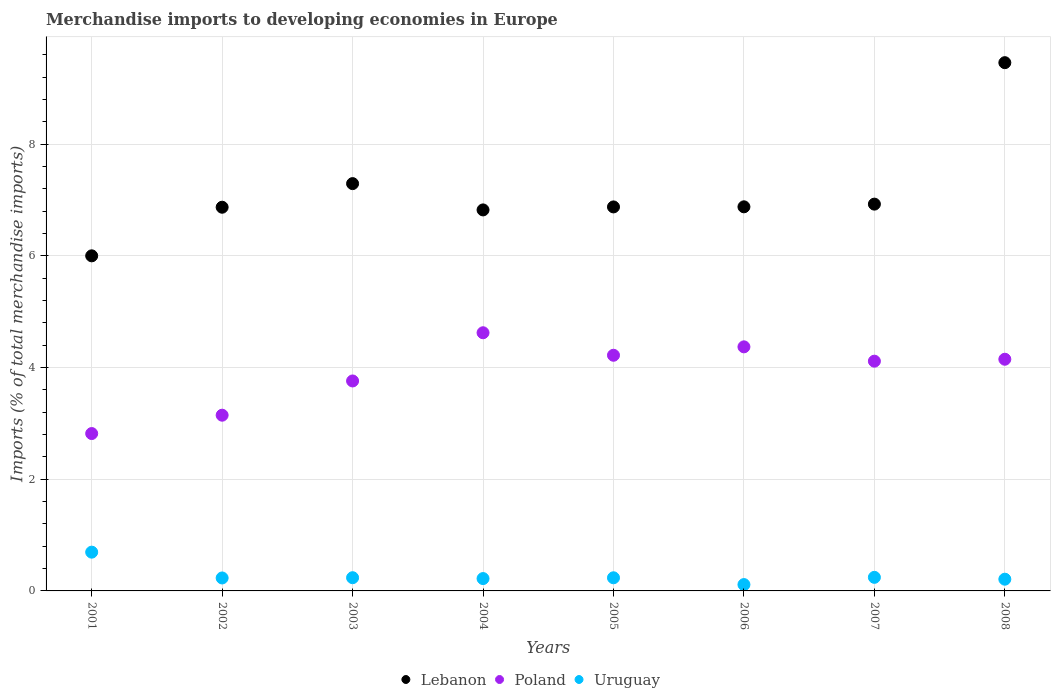How many different coloured dotlines are there?
Offer a very short reply. 3. What is the percentage total merchandise imports in Lebanon in 2005?
Give a very brief answer. 6.88. Across all years, what is the maximum percentage total merchandise imports in Lebanon?
Make the answer very short. 9.46. Across all years, what is the minimum percentage total merchandise imports in Poland?
Your response must be concise. 2.82. In which year was the percentage total merchandise imports in Lebanon maximum?
Your answer should be very brief. 2008. What is the total percentage total merchandise imports in Poland in the graph?
Ensure brevity in your answer.  31.21. What is the difference between the percentage total merchandise imports in Poland in 2001 and that in 2007?
Ensure brevity in your answer.  -1.3. What is the difference between the percentage total merchandise imports in Lebanon in 2003 and the percentage total merchandise imports in Uruguay in 2001?
Ensure brevity in your answer.  6.6. What is the average percentage total merchandise imports in Poland per year?
Provide a short and direct response. 3.9. In the year 2002, what is the difference between the percentage total merchandise imports in Lebanon and percentage total merchandise imports in Uruguay?
Offer a very short reply. 6.64. In how many years, is the percentage total merchandise imports in Lebanon greater than 1.2000000000000002 %?
Keep it short and to the point. 8. What is the ratio of the percentage total merchandise imports in Uruguay in 2007 to that in 2008?
Your answer should be compact. 1.16. Is the percentage total merchandise imports in Uruguay in 2004 less than that in 2006?
Make the answer very short. No. Is the difference between the percentage total merchandise imports in Lebanon in 2005 and 2008 greater than the difference between the percentage total merchandise imports in Uruguay in 2005 and 2008?
Make the answer very short. No. What is the difference between the highest and the second highest percentage total merchandise imports in Lebanon?
Your response must be concise. 2.17. What is the difference between the highest and the lowest percentage total merchandise imports in Lebanon?
Give a very brief answer. 3.46. In how many years, is the percentage total merchandise imports in Lebanon greater than the average percentage total merchandise imports in Lebanon taken over all years?
Provide a succinct answer. 2. Does the percentage total merchandise imports in Lebanon monotonically increase over the years?
Make the answer very short. No. Is the percentage total merchandise imports in Poland strictly greater than the percentage total merchandise imports in Uruguay over the years?
Offer a terse response. Yes. What is the difference between two consecutive major ticks on the Y-axis?
Give a very brief answer. 2. Are the values on the major ticks of Y-axis written in scientific E-notation?
Offer a terse response. No. Does the graph contain any zero values?
Your answer should be very brief. No. Does the graph contain grids?
Make the answer very short. Yes. How are the legend labels stacked?
Give a very brief answer. Horizontal. What is the title of the graph?
Your response must be concise. Merchandise imports to developing economies in Europe. Does "Uzbekistan" appear as one of the legend labels in the graph?
Offer a terse response. No. What is the label or title of the X-axis?
Make the answer very short. Years. What is the label or title of the Y-axis?
Provide a succinct answer. Imports (% of total merchandise imports). What is the Imports (% of total merchandise imports) of Lebanon in 2001?
Offer a very short reply. 6. What is the Imports (% of total merchandise imports) in Poland in 2001?
Make the answer very short. 2.82. What is the Imports (% of total merchandise imports) in Uruguay in 2001?
Your response must be concise. 0.69. What is the Imports (% of total merchandise imports) in Lebanon in 2002?
Make the answer very short. 6.87. What is the Imports (% of total merchandise imports) of Poland in 2002?
Your response must be concise. 3.15. What is the Imports (% of total merchandise imports) in Uruguay in 2002?
Provide a short and direct response. 0.23. What is the Imports (% of total merchandise imports) in Lebanon in 2003?
Provide a succinct answer. 7.3. What is the Imports (% of total merchandise imports) in Poland in 2003?
Give a very brief answer. 3.76. What is the Imports (% of total merchandise imports) of Uruguay in 2003?
Your answer should be very brief. 0.24. What is the Imports (% of total merchandise imports) of Lebanon in 2004?
Make the answer very short. 6.82. What is the Imports (% of total merchandise imports) in Poland in 2004?
Provide a short and direct response. 4.62. What is the Imports (% of total merchandise imports) of Uruguay in 2004?
Give a very brief answer. 0.22. What is the Imports (% of total merchandise imports) of Lebanon in 2005?
Your answer should be compact. 6.88. What is the Imports (% of total merchandise imports) in Poland in 2005?
Provide a short and direct response. 4.22. What is the Imports (% of total merchandise imports) of Uruguay in 2005?
Your response must be concise. 0.24. What is the Imports (% of total merchandise imports) of Lebanon in 2006?
Ensure brevity in your answer.  6.88. What is the Imports (% of total merchandise imports) in Poland in 2006?
Your answer should be compact. 4.37. What is the Imports (% of total merchandise imports) in Uruguay in 2006?
Ensure brevity in your answer.  0.11. What is the Imports (% of total merchandise imports) of Lebanon in 2007?
Your answer should be compact. 6.93. What is the Imports (% of total merchandise imports) of Poland in 2007?
Keep it short and to the point. 4.11. What is the Imports (% of total merchandise imports) of Uruguay in 2007?
Ensure brevity in your answer.  0.24. What is the Imports (% of total merchandise imports) of Lebanon in 2008?
Give a very brief answer. 9.46. What is the Imports (% of total merchandise imports) of Poland in 2008?
Your response must be concise. 4.15. What is the Imports (% of total merchandise imports) of Uruguay in 2008?
Offer a very short reply. 0.21. Across all years, what is the maximum Imports (% of total merchandise imports) of Lebanon?
Make the answer very short. 9.46. Across all years, what is the maximum Imports (% of total merchandise imports) of Poland?
Provide a succinct answer. 4.62. Across all years, what is the maximum Imports (% of total merchandise imports) in Uruguay?
Make the answer very short. 0.69. Across all years, what is the minimum Imports (% of total merchandise imports) of Lebanon?
Make the answer very short. 6. Across all years, what is the minimum Imports (% of total merchandise imports) in Poland?
Ensure brevity in your answer.  2.82. Across all years, what is the minimum Imports (% of total merchandise imports) of Uruguay?
Your answer should be very brief. 0.11. What is the total Imports (% of total merchandise imports) in Lebanon in the graph?
Ensure brevity in your answer.  57.14. What is the total Imports (% of total merchandise imports) of Poland in the graph?
Your answer should be very brief. 31.21. What is the total Imports (% of total merchandise imports) of Uruguay in the graph?
Keep it short and to the point. 2.19. What is the difference between the Imports (% of total merchandise imports) in Lebanon in 2001 and that in 2002?
Make the answer very short. -0.87. What is the difference between the Imports (% of total merchandise imports) of Poland in 2001 and that in 2002?
Offer a terse response. -0.33. What is the difference between the Imports (% of total merchandise imports) in Uruguay in 2001 and that in 2002?
Offer a very short reply. 0.46. What is the difference between the Imports (% of total merchandise imports) in Lebanon in 2001 and that in 2003?
Ensure brevity in your answer.  -1.29. What is the difference between the Imports (% of total merchandise imports) in Poland in 2001 and that in 2003?
Make the answer very short. -0.94. What is the difference between the Imports (% of total merchandise imports) of Uruguay in 2001 and that in 2003?
Give a very brief answer. 0.46. What is the difference between the Imports (% of total merchandise imports) of Lebanon in 2001 and that in 2004?
Provide a succinct answer. -0.82. What is the difference between the Imports (% of total merchandise imports) of Poland in 2001 and that in 2004?
Provide a short and direct response. -1.81. What is the difference between the Imports (% of total merchandise imports) in Uruguay in 2001 and that in 2004?
Offer a terse response. 0.47. What is the difference between the Imports (% of total merchandise imports) of Lebanon in 2001 and that in 2005?
Ensure brevity in your answer.  -0.88. What is the difference between the Imports (% of total merchandise imports) of Poland in 2001 and that in 2005?
Offer a very short reply. -1.4. What is the difference between the Imports (% of total merchandise imports) in Uruguay in 2001 and that in 2005?
Keep it short and to the point. 0.46. What is the difference between the Imports (% of total merchandise imports) of Lebanon in 2001 and that in 2006?
Provide a succinct answer. -0.88. What is the difference between the Imports (% of total merchandise imports) in Poland in 2001 and that in 2006?
Your answer should be very brief. -1.55. What is the difference between the Imports (% of total merchandise imports) in Uruguay in 2001 and that in 2006?
Your answer should be compact. 0.58. What is the difference between the Imports (% of total merchandise imports) in Lebanon in 2001 and that in 2007?
Make the answer very short. -0.93. What is the difference between the Imports (% of total merchandise imports) in Poland in 2001 and that in 2007?
Ensure brevity in your answer.  -1.3. What is the difference between the Imports (% of total merchandise imports) in Uruguay in 2001 and that in 2007?
Provide a short and direct response. 0.45. What is the difference between the Imports (% of total merchandise imports) in Lebanon in 2001 and that in 2008?
Your response must be concise. -3.46. What is the difference between the Imports (% of total merchandise imports) of Poland in 2001 and that in 2008?
Keep it short and to the point. -1.33. What is the difference between the Imports (% of total merchandise imports) in Uruguay in 2001 and that in 2008?
Your answer should be very brief. 0.48. What is the difference between the Imports (% of total merchandise imports) of Lebanon in 2002 and that in 2003?
Your answer should be compact. -0.42. What is the difference between the Imports (% of total merchandise imports) in Poland in 2002 and that in 2003?
Your answer should be compact. -0.61. What is the difference between the Imports (% of total merchandise imports) in Uruguay in 2002 and that in 2003?
Provide a short and direct response. -0. What is the difference between the Imports (% of total merchandise imports) of Lebanon in 2002 and that in 2004?
Provide a succinct answer. 0.05. What is the difference between the Imports (% of total merchandise imports) of Poland in 2002 and that in 2004?
Make the answer very short. -1.48. What is the difference between the Imports (% of total merchandise imports) in Uruguay in 2002 and that in 2004?
Give a very brief answer. 0.01. What is the difference between the Imports (% of total merchandise imports) in Lebanon in 2002 and that in 2005?
Provide a short and direct response. -0.01. What is the difference between the Imports (% of total merchandise imports) of Poland in 2002 and that in 2005?
Ensure brevity in your answer.  -1.07. What is the difference between the Imports (% of total merchandise imports) of Uruguay in 2002 and that in 2005?
Your answer should be compact. -0. What is the difference between the Imports (% of total merchandise imports) of Lebanon in 2002 and that in 2006?
Your answer should be compact. -0.01. What is the difference between the Imports (% of total merchandise imports) of Poland in 2002 and that in 2006?
Your answer should be very brief. -1.22. What is the difference between the Imports (% of total merchandise imports) in Uruguay in 2002 and that in 2006?
Offer a terse response. 0.12. What is the difference between the Imports (% of total merchandise imports) in Lebanon in 2002 and that in 2007?
Provide a short and direct response. -0.06. What is the difference between the Imports (% of total merchandise imports) of Poland in 2002 and that in 2007?
Your answer should be very brief. -0.97. What is the difference between the Imports (% of total merchandise imports) in Uruguay in 2002 and that in 2007?
Keep it short and to the point. -0.01. What is the difference between the Imports (% of total merchandise imports) of Lebanon in 2002 and that in 2008?
Offer a terse response. -2.59. What is the difference between the Imports (% of total merchandise imports) of Poland in 2002 and that in 2008?
Make the answer very short. -1. What is the difference between the Imports (% of total merchandise imports) in Uruguay in 2002 and that in 2008?
Your response must be concise. 0.02. What is the difference between the Imports (% of total merchandise imports) in Lebanon in 2003 and that in 2004?
Keep it short and to the point. 0.47. What is the difference between the Imports (% of total merchandise imports) in Poland in 2003 and that in 2004?
Make the answer very short. -0.86. What is the difference between the Imports (% of total merchandise imports) of Uruguay in 2003 and that in 2004?
Your response must be concise. 0.02. What is the difference between the Imports (% of total merchandise imports) in Lebanon in 2003 and that in 2005?
Ensure brevity in your answer.  0.42. What is the difference between the Imports (% of total merchandise imports) in Poland in 2003 and that in 2005?
Offer a terse response. -0.46. What is the difference between the Imports (% of total merchandise imports) in Uruguay in 2003 and that in 2005?
Ensure brevity in your answer.  0. What is the difference between the Imports (% of total merchandise imports) of Lebanon in 2003 and that in 2006?
Keep it short and to the point. 0.42. What is the difference between the Imports (% of total merchandise imports) of Poland in 2003 and that in 2006?
Your answer should be very brief. -0.61. What is the difference between the Imports (% of total merchandise imports) of Uruguay in 2003 and that in 2006?
Keep it short and to the point. 0.12. What is the difference between the Imports (% of total merchandise imports) in Lebanon in 2003 and that in 2007?
Give a very brief answer. 0.37. What is the difference between the Imports (% of total merchandise imports) of Poland in 2003 and that in 2007?
Make the answer very short. -0.35. What is the difference between the Imports (% of total merchandise imports) of Uruguay in 2003 and that in 2007?
Provide a succinct answer. -0.01. What is the difference between the Imports (% of total merchandise imports) in Lebanon in 2003 and that in 2008?
Give a very brief answer. -2.17. What is the difference between the Imports (% of total merchandise imports) in Poland in 2003 and that in 2008?
Make the answer very short. -0.39. What is the difference between the Imports (% of total merchandise imports) in Uruguay in 2003 and that in 2008?
Make the answer very short. 0.03. What is the difference between the Imports (% of total merchandise imports) of Lebanon in 2004 and that in 2005?
Keep it short and to the point. -0.05. What is the difference between the Imports (% of total merchandise imports) of Poland in 2004 and that in 2005?
Ensure brevity in your answer.  0.4. What is the difference between the Imports (% of total merchandise imports) of Uruguay in 2004 and that in 2005?
Make the answer very short. -0.01. What is the difference between the Imports (% of total merchandise imports) in Lebanon in 2004 and that in 2006?
Your response must be concise. -0.06. What is the difference between the Imports (% of total merchandise imports) in Poland in 2004 and that in 2006?
Your answer should be compact. 0.25. What is the difference between the Imports (% of total merchandise imports) in Uruguay in 2004 and that in 2006?
Provide a short and direct response. 0.11. What is the difference between the Imports (% of total merchandise imports) in Lebanon in 2004 and that in 2007?
Your answer should be compact. -0.1. What is the difference between the Imports (% of total merchandise imports) of Poland in 2004 and that in 2007?
Make the answer very short. 0.51. What is the difference between the Imports (% of total merchandise imports) of Uruguay in 2004 and that in 2007?
Your answer should be very brief. -0.02. What is the difference between the Imports (% of total merchandise imports) in Lebanon in 2004 and that in 2008?
Keep it short and to the point. -2.64. What is the difference between the Imports (% of total merchandise imports) of Poland in 2004 and that in 2008?
Keep it short and to the point. 0.47. What is the difference between the Imports (% of total merchandise imports) of Uruguay in 2004 and that in 2008?
Make the answer very short. 0.01. What is the difference between the Imports (% of total merchandise imports) in Lebanon in 2005 and that in 2006?
Your response must be concise. -0. What is the difference between the Imports (% of total merchandise imports) in Poland in 2005 and that in 2006?
Your answer should be very brief. -0.15. What is the difference between the Imports (% of total merchandise imports) of Uruguay in 2005 and that in 2006?
Keep it short and to the point. 0.12. What is the difference between the Imports (% of total merchandise imports) of Lebanon in 2005 and that in 2007?
Provide a short and direct response. -0.05. What is the difference between the Imports (% of total merchandise imports) of Poland in 2005 and that in 2007?
Provide a short and direct response. 0.11. What is the difference between the Imports (% of total merchandise imports) of Uruguay in 2005 and that in 2007?
Offer a very short reply. -0.01. What is the difference between the Imports (% of total merchandise imports) of Lebanon in 2005 and that in 2008?
Make the answer very short. -2.58. What is the difference between the Imports (% of total merchandise imports) of Poland in 2005 and that in 2008?
Provide a short and direct response. 0.07. What is the difference between the Imports (% of total merchandise imports) of Uruguay in 2005 and that in 2008?
Give a very brief answer. 0.03. What is the difference between the Imports (% of total merchandise imports) of Lebanon in 2006 and that in 2007?
Provide a short and direct response. -0.05. What is the difference between the Imports (% of total merchandise imports) of Poland in 2006 and that in 2007?
Provide a succinct answer. 0.26. What is the difference between the Imports (% of total merchandise imports) in Uruguay in 2006 and that in 2007?
Provide a short and direct response. -0.13. What is the difference between the Imports (% of total merchandise imports) in Lebanon in 2006 and that in 2008?
Your response must be concise. -2.58. What is the difference between the Imports (% of total merchandise imports) in Poland in 2006 and that in 2008?
Offer a terse response. 0.22. What is the difference between the Imports (% of total merchandise imports) of Uruguay in 2006 and that in 2008?
Offer a terse response. -0.1. What is the difference between the Imports (% of total merchandise imports) of Lebanon in 2007 and that in 2008?
Your answer should be very brief. -2.53. What is the difference between the Imports (% of total merchandise imports) of Poland in 2007 and that in 2008?
Make the answer very short. -0.03. What is the difference between the Imports (% of total merchandise imports) in Uruguay in 2007 and that in 2008?
Provide a short and direct response. 0.03. What is the difference between the Imports (% of total merchandise imports) of Lebanon in 2001 and the Imports (% of total merchandise imports) of Poland in 2002?
Give a very brief answer. 2.85. What is the difference between the Imports (% of total merchandise imports) of Lebanon in 2001 and the Imports (% of total merchandise imports) of Uruguay in 2002?
Make the answer very short. 5.77. What is the difference between the Imports (% of total merchandise imports) of Poland in 2001 and the Imports (% of total merchandise imports) of Uruguay in 2002?
Your response must be concise. 2.59. What is the difference between the Imports (% of total merchandise imports) in Lebanon in 2001 and the Imports (% of total merchandise imports) in Poland in 2003?
Your response must be concise. 2.24. What is the difference between the Imports (% of total merchandise imports) of Lebanon in 2001 and the Imports (% of total merchandise imports) of Uruguay in 2003?
Provide a succinct answer. 5.76. What is the difference between the Imports (% of total merchandise imports) of Poland in 2001 and the Imports (% of total merchandise imports) of Uruguay in 2003?
Offer a terse response. 2.58. What is the difference between the Imports (% of total merchandise imports) of Lebanon in 2001 and the Imports (% of total merchandise imports) of Poland in 2004?
Your answer should be compact. 1.38. What is the difference between the Imports (% of total merchandise imports) in Lebanon in 2001 and the Imports (% of total merchandise imports) in Uruguay in 2004?
Offer a very short reply. 5.78. What is the difference between the Imports (% of total merchandise imports) of Poland in 2001 and the Imports (% of total merchandise imports) of Uruguay in 2004?
Ensure brevity in your answer.  2.6. What is the difference between the Imports (% of total merchandise imports) in Lebanon in 2001 and the Imports (% of total merchandise imports) in Poland in 2005?
Your answer should be compact. 1.78. What is the difference between the Imports (% of total merchandise imports) of Lebanon in 2001 and the Imports (% of total merchandise imports) of Uruguay in 2005?
Your answer should be compact. 5.77. What is the difference between the Imports (% of total merchandise imports) of Poland in 2001 and the Imports (% of total merchandise imports) of Uruguay in 2005?
Make the answer very short. 2.58. What is the difference between the Imports (% of total merchandise imports) of Lebanon in 2001 and the Imports (% of total merchandise imports) of Poland in 2006?
Give a very brief answer. 1.63. What is the difference between the Imports (% of total merchandise imports) of Lebanon in 2001 and the Imports (% of total merchandise imports) of Uruguay in 2006?
Your answer should be compact. 5.89. What is the difference between the Imports (% of total merchandise imports) in Poland in 2001 and the Imports (% of total merchandise imports) in Uruguay in 2006?
Ensure brevity in your answer.  2.71. What is the difference between the Imports (% of total merchandise imports) in Lebanon in 2001 and the Imports (% of total merchandise imports) in Poland in 2007?
Provide a short and direct response. 1.89. What is the difference between the Imports (% of total merchandise imports) of Lebanon in 2001 and the Imports (% of total merchandise imports) of Uruguay in 2007?
Offer a very short reply. 5.76. What is the difference between the Imports (% of total merchandise imports) in Poland in 2001 and the Imports (% of total merchandise imports) in Uruguay in 2007?
Provide a short and direct response. 2.58. What is the difference between the Imports (% of total merchandise imports) in Lebanon in 2001 and the Imports (% of total merchandise imports) in Poland in 2008?
Your response must be concise. 1.85. What is the difference between the Imports (% of total merchandise imports) in Lebanon in 2001 and the Imports (% of total merchandise imports) in Uruguay in 2008?
Give a very brief answer. 5.79. What is the difference between the Imports (% of total merchandise imports) in Poland in 2001 and the Imports (% of total merchandise imports) in Uruguay in 2008?
Offer a terse response. 2.61. What is the difference between the Imports (% of total merchandise imports) of Lebanon in 2002 and the Imports (% of total merchandise imports) of Poland in 2003?
Your answer should be very brief. 3.11. What is the difference between the Imports (% of total merchandise imports) of Lebanon in 2002 and the Imports (% of total merchandise imports) of Uruguay in 2003?
Your response must be concise. 6.64. What is the difference between the Imports (% of total merchandise imports) of Poland in 2002 and the Imports (% of total merchandise imports) of Uruguay in 2003?
Give a very brief answer. 2.91. What is the difference between the Imports (% of total merchandise imports) in Lebanon in 2002 and the Imports (% of total merchandise imports) in Poland in 2004?
Provide a succinct answer. 2.25. What is the difference between the Imports (% of total merchandise imports) of Lebanon in 2002 and the Imports (% of total merchandise imports) of Uruguay in 2004?
Keep it short and to the point. 6.65. What is the difference between the Imports (% of total merchandise imports) of Poland in 2002 and the Imports (% of total merchandise imports) of Uruguay in 2004?
Your answer should be very brief. 2.93. What is the difference between the Imports (% of total merchandise imports) of Lebanon in 2002 and the Imports (% of total merchandise imports) of Poland in 2005?
Offer a very short reply. 2.65. What is the difference between the Imports (% of total merchandise imports) of Lebanon in 2002 and the Imports (% of total merchandise imports) of Uruguay in 2005?
Ensure brevity in your answer.  6.64. What is the difference between the Imports (% of total merchandise imports) of Poland in 2002 and the Imports (% of total merchandise imports) of Uruguay in 2005?
Give a very brief answer. 2.91. What is the difference between the Imports (% of total merchandise imports) of Lebanon in 2002 and the Imports (% of total merchandise imports) of Poland in 2006?
Your response must be concise. 2.5. What is the difference between the Imports (% of total merchandise imports) of Lebanon in 2002 and the Imports (% of total merchandise imports) of Uruguay in 2006?
Give a very brief answer. 6.76. What is the difference between the Imports (% of total merchandise imports) in Poland in 2002 and the Imports (% of total merchandise imports) in Uruguay in 2006?
Give a very brief answer. 3.03. What is the difference between the Imports (% of total merchandise imports) in Lebanon in 2002 and the Imports (% of total merchandise imports) in Poland in 2007?
Give a very brief answer. 2.76. What is the difference between the Imports (% of total merchandise imports) in Lebanon in 2002 and the Imports (% of total merchandise imports) in Uruguay in 2007?
Your answer should be very brief. 6.63. What is the difference between the Imports (% of total merchandise imports) of Poland in 2002 and the Imports (% of total merchandise imports) of Uruguay in 2007?
Offer a very short reply. 2.9. What is the difference between the Imports (% of total merchandise imports) in Lebanon in 2002 and the Imports (% of total merchandise imports) in Poland in 2008?
Offer a very short reply. 2.72. What is the difference between the Imports (% of total merchandise imports) of Lebanon in 2002 and the Imports (% of total merchandise imports) of Uruguay in 2008?
Your response must be concise. 6.66. What is the difference between the Imports (% of total merchandise imports) in Poland in 2002 and the Imports (% of total merchandise imports) in Uruguay in 2008?
Your response must be concise. 2.94. What is the difference between the Imports (% of total merchandise imports) in Lebanon in 2003 and the Imports (% of total merchandise imports) in Poland in 2004?
Provide a short and direct response. 2.67. What is the difference between the Imports (% of total merchandise imports) in Lebanon in 2003 and the Imports (% of total merchandise imports) in Uruguay in 2004?
Keep it short and to the point. 7.07. What is the difference between the Imports (% of total merchandise imports) in Poland in 2003 and the Imports (% of total merchandise imports) in Uruguay in 2004?
Provide a succinct answer. 3.54. What is the difference between the Imports (% of total merchandise imports) in Lebanon in 2003 and the Imports (% of total merchandise imports) in Poland in 2005?
Offer a very short reply. 3.07. What is the difference between the Imports (% of total merchandise imports) of Lebanon in 2003 and the Imports (% of total merchandise imports) of Uruguay in 2005?
Your answer should be very brief. 7.06. What is the difference between the Imports (% of total merchandise imports) in Poland in 2003 and the Imports (% of total merchandise imports) in Uruguay in 2005?
Offer a very short reply. 3.53. What is the difference between the Imports (% of total merchandise imports) of Lebanon in 2003 and the Imports (% of total merchandise imports) of Poland in 2006?
Keep it short and to the point. 2.92. What is the difference between the Imports (% of total merchandise imports) in Lebanon in 2003 and the Imports (% of total merchandise imports) in Uruguay in 2006?
Make the answer very short. 7.18. What is the difference between the Imports (% of total merchandise imports) in Poland in 2003 and the Imports (% of total merchandise imports) in Uruguay in 2006?
Ensure brevity in your answer.  3.65. What is the difference between the Imports (% of total merchandise imports) of Lebanon in 2003 and the Imports (% of total merchandise imports) of Poland in 2007?
Ensure brevity in your answer.  3.18. What is the difference between the Imports (% of total merchandise imports) of Lebanon in 2003 and the Imports (% of total merchandise imports) of Uruguay in 2007?
Your response must be concise. 7.05. What is the difference between the Imports (% of total merchandise imports) in Poland in 2003 and the Imports (% of total merchandise imports) in Uruguay in 2007?
Offer a very short reply. 3.52. What is the difference between the Imports (% of total merchandise imports) of Lebanon in 2003 and the Imports (% of total merchandise imports) of Poland in 2008?
Offer a terse response. 3.15. What is the difference between the Imports (% of total merchandise imports) in Lebanon in 2003 and the Imports (% of total merchandise imports) in Uruguay in 2008?
Keep it short and to the point. 7.08. What is the difference between the Imports (% of total merchandise imports) of Poland in 2003 and the Imports (% of total merchandise imports) of Uruguay in 2008?
Your answer should be compact. 3.55. What is the difference between the Imports (% of total merchandise imports) in Lebanon in 2004 and the Imports (% of total merchandise imports) in Poland in 2005?
Offer a terse response. 2.6. What is the difference between the Imports (% of total merchandise imports) in Lebanon in 2004 and the Imports (% of total merchandise imports) in Uruguay in 2005?
Your answer should be compact. 6.59. What is the difference between the Imports (% of total merchandise imports) of Poland in 2004 and the Imports (% of total merchandise imports) of Uruguay in 2005?
Your answer should be very brief. 4.39. What is the difference between the Imports (% of total merchandise imports) in Lebanon in 2004 and the Imports (% of total merchandise imports) in Poland in 2006?
Your response must be concise. 2.45. What is the difference between the Imports (% of total merchandise imports) in Lebanon in 2004 and the Imports (% of total merchandise imports) in Uruguay in 2006?
Make the answer very short. 6.71. What is the difference between the Imports (% of total merchandise imports) of Poland in 2004 and the Imports (% of total merchandise imports) of Uruguay in 2006?
Your answer should be compact. 4.51. What is the difference between the Imports (% of total merchandise imports) in Lebanon in 2004 and the Imports (% of total merchandise imports) in Poland in 2007?
Your answer should be compact. 2.71. What is the difference between the Imports (% of total merchandise imports) in Lebanon in 2004 and the Imports (% of total merchandise imports) in Uruguay in 2007?
Keep it short and to the point. 6.58. What is the difference between the Imports (% of total merchandise imports) in Poland in 2004 and the Imports (% of total merchandise imports) in Uruguay in 2007?
Your answer should be compact. 4.38. What is the difference between the Imports (% of total merchandise imports) in Lebanon in 2004 and the Imports (% of total merchandise imports) in Poland in 2008?
Your answer should be very brief. 2.67. What is the difference between the Imports (% of total merchandise imports) in Lebanon in 2004 and the Imports (% of total merchandise imports) in Uruguay in 2008?
Your response must be concise. 6.61. What is the difference between the Imports (% of total merchandise imports) of Poland in 2004 and the Imports (% of total merchandise imports) of Uruguay in 2008?
Provide a short and direct response. 4.41. What is the difference between the Imports (% of total merchandise imports) in Lebanon in 2005 and the Imports (% of total merchandise imports) in Poland in 2006?
Offer a terse response. 2.51. What is the difference between the Imports (% of total merchandise imports) in Lebanon in 2005 and the Imports (% of total merchandise imports) in Uruguay in 2006?
Your answer should be very brief. 6.76. What is the difference between the Imports (% of total merchandise imports) of Poland in 2005 and the Imports (% of total merchandise imports) of Uruguay in 2006?
Make the answer very short. 4.11. What is the difference between the Imports (% of total merchandise imports) in Lebanon in 2005 and the Imports (% of total merchandise imports) in Poland in 2007?
Ensure brevity in your answer.  2.76. What is the difference between the Imports (% of total merchandise imports) of Lebanon in 2005 and the Imports (% of total merchandise imports) of Uruguay in 2007?
Offer a very short reply. 6.63. What is the difference between the Imports (% of total merchandise imports) of Poland in 2005 and the Imports (% of total merchandise imports) of Uruguay in 2007?
Your answer should be very brief. 3.98. What is the difference between the Imports (% of total merchandise imports) of Lebanon in 2005 and the Imports (% of total merchandise imports) of Poland in 2008?
Offer a very short reply. 2.73. What is the difference between the Imports (% of total merchandise imports) of Lebanon in 2005 and the Imports (% of total merchandise imports) of Uruguay in 2008?
Keep it short and to the point. 6.67. What is the difference between the Imports (% of total merchandise imports) of Poland in 2005 and the Imports (% of total merchandise imports) of Uruguay in 2008?
Offer a terse response. 4.01. What is the difference between the Imports (% of total merchandise imports) in Lebanon in 2006 and the Imports (% of total merchandise imports) in Poland in 2007?
Your answer should be very brief. 2.76. What is the difference between the Imports (% of total merchandise imports) of Lebanon in 2006 and the Imports (% of total merchandise imports) of Uruguay in 2007?
Make the answer very short. 6.64. What is the difference between the Imports (% of total merchandise imports) in Poland in 2006 and the Imports (% of total merchandise imports) in Uruguay in 2007?
Offer a very short reply. 4.13. What is the difference between the Imports (% of total merchandise imports) of Lebanon in 2006 and the Imports (% of total merchandise imports) of Poland in 2008?
Ensure brevity in your answer.  2.73. What is the difference between the Imports (% of total merchandise imports) of Lebanon in 2006 and the Imports (% of total merchandise imports) of Uruguay in 2008?
Make the answer very short. 6.67. What is the difference between the Imports (% of total merchandise imports) of Poland in 2006 and the Imports (% of total merchandise imports) of Uruguay in 2008?
Offer a very short reply. 4.16. What is the difference between the Imports (% of total merchandise imports) in Lebanon in 2007 and the Imports (% of total merchandise imports) in Poland in 2008?
Offer a very short reply. 2.78. What is the difference between the Imports (% of total merchandise imports) in Lebanon in 2007 and the Imports (% of total merchandise imports) in Uruguay in 2008?
Your answer should be very brief. 6.72. What is the difference between the Imports (% of total merchandise imports) in Poland in 2007 and the Imports (% of total merchandise imports) in Uruguay in 2008?
Make the answer very short. 3.9. What is the average Imports (% of total merchandise imports) of Lebanon per year?
Your answer should be very brief. 7.14. What is the average Imports (% of total merchandise imports) in Poland per year?
Your answer should be very brief. 3.9. What is the average Imports (% of total merchandise imports) in Uruguay per year?
Your answer should be very brief. 0.27. In the year 2001, what is the difference between the Imports (% of total merchandise imports) in Lebanon and Imports (% of total merchandise imports) in Poland?
Make the answer very short. 3.18. In the year 2001, what is the difference between the Imports (% of total merchandise imports) of Lebanon and Imports (% of total merchandise imports) of Uruguay?
Offer a very short reply. 5.31. In the year 2001, what is the difference between the Imports (% of total merchandise imports) in Poland and Imports (% of total merchandise imports) in Uruguay?
Provide a succinct answer. 2.12. In the year 2002, what is the difference between the Imports (% of total merchandise imports) in Lebanon and Imports (% of total merchandise imports) in Poland?
Provide a short and direct response. 3.72. In the year 2002, what is the difference between the Imports (% of total merchandise imports) of Lebanon and Imports (% of total merchandise imports) of Uruguay?
Your response must be concise. 6.64. In the year 2002, what is the difference between the Imports (% of total merchandise imports) in Poland and Imports (% of total merchandise imports) in Uruguay?
Provide a short and direct response. 2.92. In the year 2003, what is the difference between the Imports (% of total merchandise imports) in Lebanon and Imports (% of total merchandise imports) in Poland?
Provide a short and direct response. 3.53. In the year 2003, what is the difference between the Imports (% of total merchandise imports) of Lebanon and Imports (% of total merchandise imports) of Uruguay?
Give a very brief answer. 7.06. In the year 2003, what is the difference between the Imports (% of total merchandise imports) in Poland and Imports (% of total merchandise imports) in Uruguay?
Make the answer very short. 3.52. In the year 2004, what is the difference between the Imports (% of total merchandise imports) of Lebanon and Imports (% of total merchandise imports) of Poland?
Your answer should be very brief. 2.2. In the year 2004, what is the difference between the Imports (% of total merchandise imports) of Lebanon and Imports (% of total merchandise imports) of Uruguay?
Make the answer very short. 6.6. In the year 2004, what is the difference between the Imports (% of total merchandise imports) of Poland and Imports (% of total merchandise imports) of Uruguay?
Ensure brevity in your answer.  4.4. In the year 2005, what is the difference between the Imports (% of total merchandise imports) of Lebanon and Imports (% of total merchandise imports) of Poland?
Your answer should be very brief. 2.66. In the year 2005, what is the difference between the Imports (% of total merchandise imports) in Lebanon and Imports (% of total merchandise imports) in Uruguay?
Ensure brevity in your answer.  6.64. In the year 2005, what is the difference between the Imports (% of total merchandise imports) of Poland and Imports (% of total merchandise imports) of Uruguay?
Provide a short and direct response. 3.99. In the year 2006, what is the difference between the Imports (% of total merchandise imports) of Lebanon and Imports (% of total merchandise imports) of Poland?
Your response must be concise. 2.51. In the year 2006, what is the difference between the Imports (% of total merchandise imports) of Lebanon and Imports (% of total merchandise imports) of Uruguay?
Offer a terse response. 6.77. In the year 2006, what is the difference between the Imports (% of total merchandise imports) of Poland and Imports (% of total merchandise imports) of Uruguay?
Your response must be concise. 4.26. In the year 2007, what is the difference between the Imports (% of total merchandise imports) in Lebanon and Imports (% of total merchandise imports) in Poland?
Provide a short and direct response. 2.81. In the year 2007, what is the difference between the Imports (% of total merchandise imports) in Lebanon and Imports (% of total merchandise imports) in Uruguay?
Offer a very short reply. 6.68. In the year 2007, what is the difference between the Imports (% of total merchandise imports) in Poland and Imports (% of total merchandise imports) in Uruguay?
Provide a succinct answer. 3.87. In the year 2008, what is the difference between the Imports (% of total merchandise imports) in Lebanon and Imports (% of total merchandise imports) in Poland?
Give a very brief answer. 5.31. In the year 2008, what is the difference between the Imports (% of total merchandise imports) of Lebanon and Imports (% of total merchandise imports) of Uruguay?
Provide a succinct answer. 9.25. In the year 2008, what is the difference between the Imports (% of total merchandise imports) of Poland and Imports (% of total merchandise imports) of Uruguay?
Your answer should be compact. 3.94. What is the ratio of the Imports (% of total merchandise imports) of Lebanon in 2001 to that in 2002?
Your answer should be very brief. 0.87. What is the ratio of the Imports (% of total merchandise imports) of Poland in 2001 to that in 2002?
Offer a very short reply. 0.9. What is the ratio of the Imports (% of total merchandise imports) in Uruguay in 2001 to that in 2002?
Give a very brief answer. 2.99. What is the ratio of the Imports (% of total merchandise imports) in Lebanon in 2001 to that in 2003?
Your answer should be compact. 0.82. What is the ratio of the Imports (% of total merchandise imports) in Poland in 2001 to that in 2003?
Offer a very short reply. 0.75. What is the ratio of the Imports (% of total merchandise imports) in Uruguay in 2001 to that in 2003?
Offer a very short reply. 2.93. What is the ratio of the Imports (% of total merchandise imports) in Lebanon in 2001 to that in 2004?
Keep it short and to the point. 0.88. What is the ratio of the Imports (% of total merchandise imports) in Poland in 2001 to that in 2004?
Your response must be concise. 0.61. What is the ratio of the Imports (% of total merchandise imports) in Uruguay in 2001 to that in 2004?
Offer a very short reply. 3.14. What is the ratio of the Imports (% of total merchandise imports) of Lebanon in 2001 to that in 2005?
Give a very brief answer. 0.87. What is the ratio of the Imports (% of total merchandise imports) in Poland in 2001 to that in 2005?
Offer a very short reply. 0.67. What is the ratio of the Imports (% of total merchandise imports) of Uruguay in 2001 to that in 2005?
Make the answer very short. 2.95. What is the ratio of the Imports (% of total merchandise imports) in Lebanon in 2001 to that in 2006?
Give a very brief answer. 0.87. What is the ratio of the Imports (% of total merchandise imports) in Poland in 2001 to that in 2006?
Provide a short and direct response. 0.64. What is the ratio of the Imports (% of total merchandise imports) in Uruguay in 2001 to that in 2006?
Make the answer very short. 6.11. What is the ratio of the Imports (% of total merchandise imports) in Lebanon in 2001 to that in 2007?
Give a very brief answer. 0.87. What is the ratio of the Imports (% of total merchandise imports) in Poland in 2001 to that in 2007?
Provide a short and direct response. 0.69. What is the ratio of the Imports (% of total merchandise imports) of Uruguay in 2001 to that in 2007?
Your response must be concise. 2.86. What is the ratio of the Imports (% of total merchandise imports) in Lebanon in 2001 to that in 2008?
Offer a terse response. 0.63. What is the ratio of the Imports (% of total merchandise imports) in Poland in 2001 to that in 2008?
Provide a succinct answer. 0.68. What is the ratio of the Imports (% of total merchandise imports) of Uruguay in 2001 to that in 2008?
Provide a short and direct response. 3.3. What is the ratio of the Imports (% of total merchandise imports) of Lebanon in 2002 to that in 2003?
Your answer should be very brief. 0.94. What is the ratio of the Imports (% of total merchandise imports) in Poland in 2002 to that in 2003?
Your answer should be very brief. 0.84. What is the ratio of the Imports (% of total merchandise imports) of Uruguay in 2002 to that in 2003?
Provide a short and direct response. 0.98. What is the ratio of the Imports (% of total merchandise imports) in Lebanon in 2002 to that in 2004?
Keep it short and to the point. 1.01. What is the ratio of the Imports (% of total merchandise imports) in Poland in 2002 to that in 2004?
Offer a terse response. 0.68. What is the ratio of the Imports (% of total merchandise imports) of Uruguay in 2002 to that in 2004?
Make the answer very short. 1.05. What is the ratio of the Imports (% of total merchandise imports) in Poland in 2002 to that in 2005?
Your answer should be very brief. 0.75. What is the ratio of the Imports (% of total merchandise imports) in Uruguay in 2002 to that in 2005?
Provide a succinct answer. 0.99. What is the ratio of the Imports (% of total merchandise imports) in Lebanon in 2002 to that in 2006?
Offer a terse response. 1. What is the ratio of the Imports (% of total merchandise imports) in Poland in 2002 to that in 2006?
Provide a short and direct response. 0.72. What is the ratio of the Imports (% of total merchandise imports) of Uruguay in 2002 to that in 2006?
Keep it short and to the point. 2.04. What is the ratio of the Imports (% of total merchandise imports) in Lebanon in 2002 to that in 2007?
Provide a short and direct response. 0.99. What is the ratio of the Imports (% of total merchandise imports) in Poland in 2002 to that in 2007?
Offer a very short reply. 0.76. What is the ratio of the Imports (% of total merchandise imports) of Uruguay in 2002 to that in 2007?
Your answer should be compact. 0.95. What is the ratio of the Imports (% of total merchandise imports) in Lebanon in 2002 to that in 2008?
Offer a terse response. 0.73. What is the ratio of the Imports (% of total merchandise imports) in Poland in 2002 to that in 2008?
Provide a short and direct response. 0.76. What is the ratio of the Imports (% of total merchandise imports) of Uruguay in 2002 to that in 2008?
Give a very brief answer. 1.1. What is the ratio of the Imports (% of total merchandise imports) in Lebanon in 2003 to that in 2004?
Provide a short and direct response. 1.07. What is the ratio of the Imports (% of total merchandise imports) in Poland in 2003 to that in 2004?
Your response must be concise. 0.81. What is the ratio of the Imports (% of total merchandise imports) of Uruguay in 2003 to that in 2004?
Provide a succinct answer. 1.07. What is the ratio of the Imports (% of total merchandise imports) of Lebanon in 2003 to that in 2005?
Your answer should be very brief. 1.06. What is the ratio of the Imports (% of total merchandise imports) of Poland in 2003 to that in 2005?
Your response must be concise. 0.89. What is the ratio of the Imports (% of total merchandise imports) in Lebanon in 2003 to that in 2006?
Give a very brief answer. 1.06. What is the ratio of the Imports (% of total merchandise imports) in Poland in 2003 to that in 2006?
Make the answer very short. 0.86. What is the ratio of the Imports (% of total merchandise imports) of Uruguay in 2003 to that in 2006?
Your response must be concise. 2.08. What is the ratio of the Imports (% of total merchandise imports) in Lebanon in 2003 to that in 2007?
Give a very brief answer. 1.05. What is the ratio of the Imports (% of total merchandise imports) in Poland in 2003 to that in 2007?
Keep it short and to the point. 0.91. What is the ratio of the Imports (% of total merchandise imports) in Uruguay in 2003 to that in 2007?
Your response must be concise. 0.97. What is the ratio of the Imports (% of total merchandise imports) of Lebanon in 2003 to that in 2008?
Give a very brief answer. 0.77. What is the ratio of the Imports (% of total merchandise imports) in Poland in 2003 to that in 2008?
Your answer should be compact. 0.91. What is the ratio of the Imports (% of total merchandise imports) of Uruguay in 2003 to that in 2008?
Provide a succinct answer. 1.13. What is the ratio of the Imports (% of total merchandise imports) in Lebanon in 2004 to that in 2005?
Your answer should be compact. 0.99. What is the ratio of the Imports (% of total merchandise imports) of Poland in 2004 to that in 2005?
Provide a succinct answer. 1.1. What is the ratio of the Imports (% of total merchandise imports) in Uruguay in 2004 to that in 2005?
Keep it short and to the point. 0.94. What is the ratio of the Imports (% of total merchandise imports) in Lebanon in 2004 to that in 2006?
Your answer should be compact. 0.99. What is the ratio of the Imports (% of total merchandise imports) in Poland in 2004 to that in 2006?
Provide a short and direct response. 1.06. What is the ratio of the Imports (% of total merchandise imports) in Uruguay in 2004 to that in 2006?
Make the answer very short. 1.95. What is the ratio of the Imports (% of total merchandise imports) in Lebanon in 2004 to that in 2007?
Give a very brief answer. 0.99. What is the ratio of the Imports (% of total merchandise imports) of Poland in 2004 to that in 2007?
Make the answer very short. 1.12. What is the ratio of the Imports (% of total merchandise imports) of Uruguay in 2004 to that in 2007?
Offer a terse response. 0.91. What is the ratio of the Imports (% of total merchandise imports) in Lebanon in 2004 to that in 2008?
Your answer should be very brief. 0.72. What is the ratio of the Imports (% of total merchandise imports) of Poland in 2004 to that in 2008?
Ensure brevity in your answer.  1.11. What is the ratio of the Imports (% of total merchandise imports) in Uruguay in 2004 to that in 2008?
Ensure brevity in your answer.  1.05. What is the ratio of the Imports (% of total merchandise imports) in Lebanon in 2005 to that in 2006?
Make the answer very short. 1. What is the ratio of the Imports (% of total merchandise imports) of Poland in 2005 to that in 2006?
Provide a short and direct response. 0.97. What is the ratio of the Imports (% of total merchandise imports) in Uruguay in 2005 to that in 2006?
Offer a very short reply. 2.07. What is the ratio of the Imports (% of total merchandise imports) of Lebanon in 2005 to that in 2007?
Offer a terse response. 0.99. What is the ratio of the Imports (% of total merchandise imports) in Poland in 2005 to that in 2007?
Your answer should be very brief. 1.03. What is the ratio of the Imports (% of total merchandise imports) of Uruguay in 2005 to that in 2007?
Give a very brief answer. 0.97. What is the ratio of the Imports (% of total merchandise imports) of Lebanon in 2005 to that in 2008?
Offer a very short reply. 0.73. What is the ratio of the Imports (% of total merchandise imports) in Poland in 2005 to that in 2008?
Ensure brevity in your answer.  1.02. What is the ratio of the Imports (% of total merchandise imports) of Uruguay in 2005 to that in 2008?
Offer a terse response. 1.12. What is the ratio of the Imports (% of total merchandise imports) of Lebanon in 2006 to that in 2007?
Make the answer very short. 0.99. What is the ratio of the Imports (% of total merchandise imports) of Poland in 2006 to that in 2007?
Keep it short and to the point. 1.06. What is the ratio of the Imports (% of total merchandise imports) of Uruguay in 2006 to that in 2007?
Provide a short and direct response. 0.47. What is the ratio of the Imports (% of total merchandise imports) in Lebanon in 2006 to that in 2008?
Your answer should be very brief. 0.73. What is the ratio of the Imports (% of total merchandise imports) in Poland in 2006 to that in 2008?
Make the answer very short. 1.05. What is the ratio of the Imports (% of total merchandise imports) in Uruguay in 2006 to that in 2008?
Your answer should be compact. 0.54. What is the ratio of the Imports (% of total merchandise imports) in Lebanon in 2007 to that in 2008?
Provide a short and direct response. 0.73. What is the ratio of the Imports (% of total merchandise imports) of Poland in 2007 to that in 2008?
Your answer should be compact. 0.99. What is the ratio of the Imports (% of total merchandise imports) in Uruguay in 2007 to that in 2008?
Give a very brief answer. 1.16. What is the difference between the highest and the second highest Imports (% of total merchandise imports) of Lebanon?
Your answer should be compact. 2.17. What is the difference between the highest and the second highest Imports (% of total merchandise imports) of Poland?
Keep it short and to the point. 0.25. What is the difference between the highest and the second highest Imports (% of total merchandise imports) of Uruguay?
Provide a succinct answer. 0.45. What is the difference between the highest and the lowest Imports (% of total merchandise imports) of Lebanon?
Provide a succinct answer. 3.46. What is the difference between the highest and the lowest Imports (% of total merchandise imports) of Poland?
Your response must be concise. 1.81. What is the difference between the highest and the lowest Imports (% of total merchandise imports) in Uruguay?
Keep it short and to the point. 0.58. 